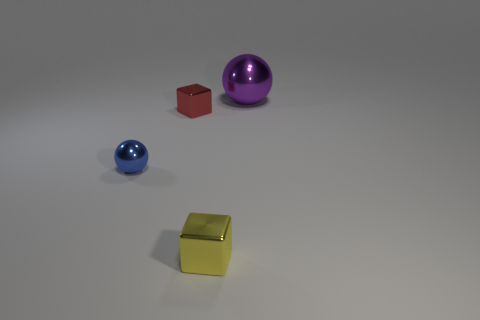What is the shape of the purple object that is the same material as the yellow block?
Provide a succinct answer. Sphere. Is there a small ball?
Give a very brief answer. Yes. Are there fewer tiny yellow metallic blocks that are behind the small yellow thing than metal cubes that are on the right side of the red shiny thing?
Make the answer very short. Yes. The tiny object in front of the blue sphere has what shape?
Ensure brevity in your answer.  Cube. Is the small blue thing made of the same material as the big sphere?
Offer a terse response. Yes. Is there any other thing that has the same material as the purple ball?
Offer a very short reply. Yes. There is another tiny object that is the same shape as the purple thing; what is it made of?
Your answer should be compact. Metal. Are there fewer small red metallic objects behind the big purple metallic sphere than large purple objects?
Provide a succinct answer. Yes. What number of large spheres are left of the large purple shiny object?
Keep it short and to the point. 0. Does the small blue thing that is to the left of the yellow metallic object have the same shape as the tiny shiny thing right of the tiny red shiny object?
Keep it short and to the point. No. 